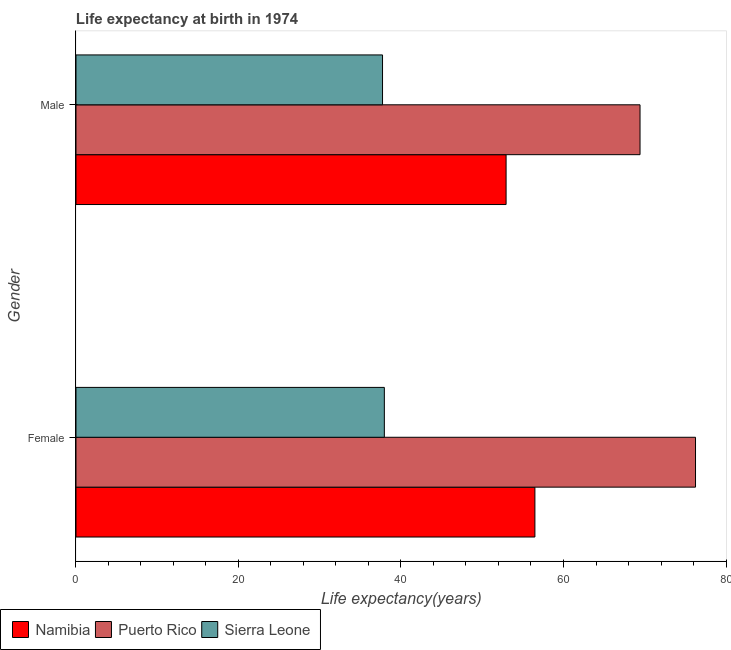How many different coloured bars are there?
Provide a short and direct response. 3. Are the number of bars per tick equal to the number of legend labels?
Make the answer very short. Yes. How many bars are there on the 1st tick from the top?
Your answer should be compact. 3. What is the label of the 2nd group of bars from the top?
Keep it short and to the point. Female. What is the life expectancy(male) in Sierra Leone?
Your response must be concise. 37.73. Across all countries, what is the maximum life expectancy(male)?
Provide a short and direct response. 69.42. Across all countries, what is the minimum life expectancy(female)?
Your answer should be very brief. 37.95. In which country was the life expectancy(female) maximum?
Your answer should be compact. Puerto Rico. In which country was the life expectancy(male) minimum?
Your answer should be very brief. Sierra Leone. What is the total life expectancy(male) in the graph?
Make the answer very short. 160.08. What is the difference between the life expectancy(male) in Puerto Rico and that in Sierra Leone?
Keep it short and to the point. 31.69. What is the difference between the life expectancy(female) in Sierra Leone and the life expectancy(male) in Namibia?
Provide a succinct answer. -14.98. What is the average life expectancy(female) per country?
Provide a short and direct response. 56.89. What is the difference between the life expectancy(female) and life expectancy(male) in Puerto Rico?
Your response must be concise. 6.83. What is the ratio of the life expectancy(male) in Puerto Rico to that in Namibia?
Your response must be concise. 1.31. In how many countries, is the life expectancy(male) greater than the average life expectancy(male) taken over all countries?
Your response must be concise. 1. What does the 1st bar from the top in Female represents?
Provide a short and direct response. Sierra Leone. What does the 3rd bar from the bottom in Male represents?
Make the answer very short. Sierra Leone. How many bars are there?
Give a very brief answer. 6. Are all the bars in the graph horizontal?
Offer a very short reply. Yes. Are the values on the major ticks of X-axis written in scientific E-notation?
Make the answer very short. No. What is the title of the graph?
Offer a terse response. Life expectancy at birth in 1974. What is the label or title of the X-axis?
Your answer should be compact. Life expectancy(years). What is the label or title of the Y-axis?
Your answer should be compact. Gender. What is the Life expectancy(years) in Namibia in Female?
Provide a succinct answer. 56.48. What is the Life expectancy(years) in Puerto Rico in Female?
Make the answer very short. 76.25. What is the Life expectancy(years) in Sierra Leone in Female?
Give a very brief answer. 37.95. What is the Life expectancy(years) of Namibia in Male?
Offer a terse response. 52.94. What is the Life expectancy(years) in Puerto Rico in Male?
Make the answer very short. 69.42. What is the Life expectancy(years) in Sierra Leone in Male?
Offer a terse response. 37.73. Across all Gender, what is the maximum Life expectancy(years) in Namibia?
Provide a succinct answer. 56.48. Across all Gender, what is the maximum Life expectancy(years) in Puerto Rico?
Provide a succinct answer. 76.25. Across all Gender, what is the maximum Life expectancy(years) of Sierra Leone?
Provide a succinct answer. 37.95. Across all Gender, what is the minimum Life expectancy(years) of Namibia?
Make the answer very short. 52.94. Across all Gender, what is the minimum Life expectancy(years) in Puerto Rico?
Your response must be concise. 69.42. Across all Gender, what is the minimum Life expectancy(years) in Sierra Leone?
Offer a terse response. 37.73. What is the total Life expectancy(years) in Namibia in the graph?
Provide a succinct answer. 109.42. What is the total Life expectancy(years) of Puerto Rico in the graph?
Provide a short and direct response. 145.67. What is the total Life expectancy(years) in Sierra Leone in the graph?
Your response must be concise. 75.68. What is the difference between the Life expectancy(years) of Namibia in Female and that in Male?
Offer a very short reply. 3.55. What is the difference between the Life expectancy(years) of Puerto Rico in Female and that in Male?
Your response must be concise. 6.83. What is the difference between the Life expectancy(years) of Sierra Leone in Female and that in Male?
Your answer should be compact. 0.22. What is the difference between the Life expectancy(years) in Namibia in Female and the Life expectancy(years) in Puerto Rico in Male?
Your response must be concise. -12.94. What is the difference between the Life expectancy(years) in Namibia in Female and the Life expectancy(years) in Sierra Leone in Male?
Provide a succinct answer. 18.75. What is the difference between the Life expectancy(years) in Puerto Rico in Female and the Life expectancy(years) in Sierra Leone in Male?
Provide a short and direct response. 38.52. What is the average Life expectancy(years) in Namibia per Gender?
Provide a short and direct response. 54.71. What is the average Life expectancy(years) of Puerto Rico per Gender?
Keep it short and to the point. 72.83. What is the average Life expectancy(years) of Sierra Leone per Gender?
Keep it short and to the point. 37.84. What is the difference between the Life expectancy(years) in Namibia and Life expectancy(years) in Puerto Rico in Female?
Give a very brief answer. -19.77. What is the difference between the Life expectancy(years) in Namibia and Life expectancy(years) in Sierra Leone in Female?
Ensure brevity in your answer.  18.53. What is the difference between the Life expectancy(years) in Puerto Rico and Life expectancy(years) in Sierra Leone in Female?
Offer a terse response. 38.3. What is the difference between the Life expectancy(years) in Namibia and Life expectancy(years) in Puerto Rico in Male?
Provide a succinct answer. -16.48. What is the difference between the Life expectancy(years) in Namibia and Life expectancy(years) in Sierra Leone in Male?
Provide a succinct answer. 15.21. What is the difference between the Life expectancy(years) in Puerto Rico and Life expectancy(years) in Sierra Leone in Male?
Give a very brief answer. 31.69. What is the ratio of the Life expectancy(years) in Namibia in Female to that in Male?
Provide a short and direct response. 1.07. What is the ratio of the Life expectancy(years) in Puerto Rico in Female to that in Male?
Provide a succinct answer. 1.1. What is the ratio of the Life expectancy(years) in Sierra Leone in Female to that in Male?
Make the answer very short. 1.01. What is the difference between the highest and the second highest Life expectancy(years) in Namibia?
Provide a short and direct response. 3.55. What is the difference between the highest and the second highest Life expectancy(years) in Puerto Rico?
Provide a short and direct response. 6.83. What is the difference between the highest and the second highest Life expectancy(years) of Sierra Leone?
Give a very brief answer. 0.22. What is the difference between the highest and the lowest Life expectancy(years) of Namibia?
Ensure brevity in your answer.  3.55. What is the difference between the highest and the lowest Life expectancy(years) in Puerto Rico?
Give a very brief answer. 6.83. What is the difference between the highest and the lowest Life expectancy(years) of Sierra Leone?
Keep it short and to the point. 0.22. 